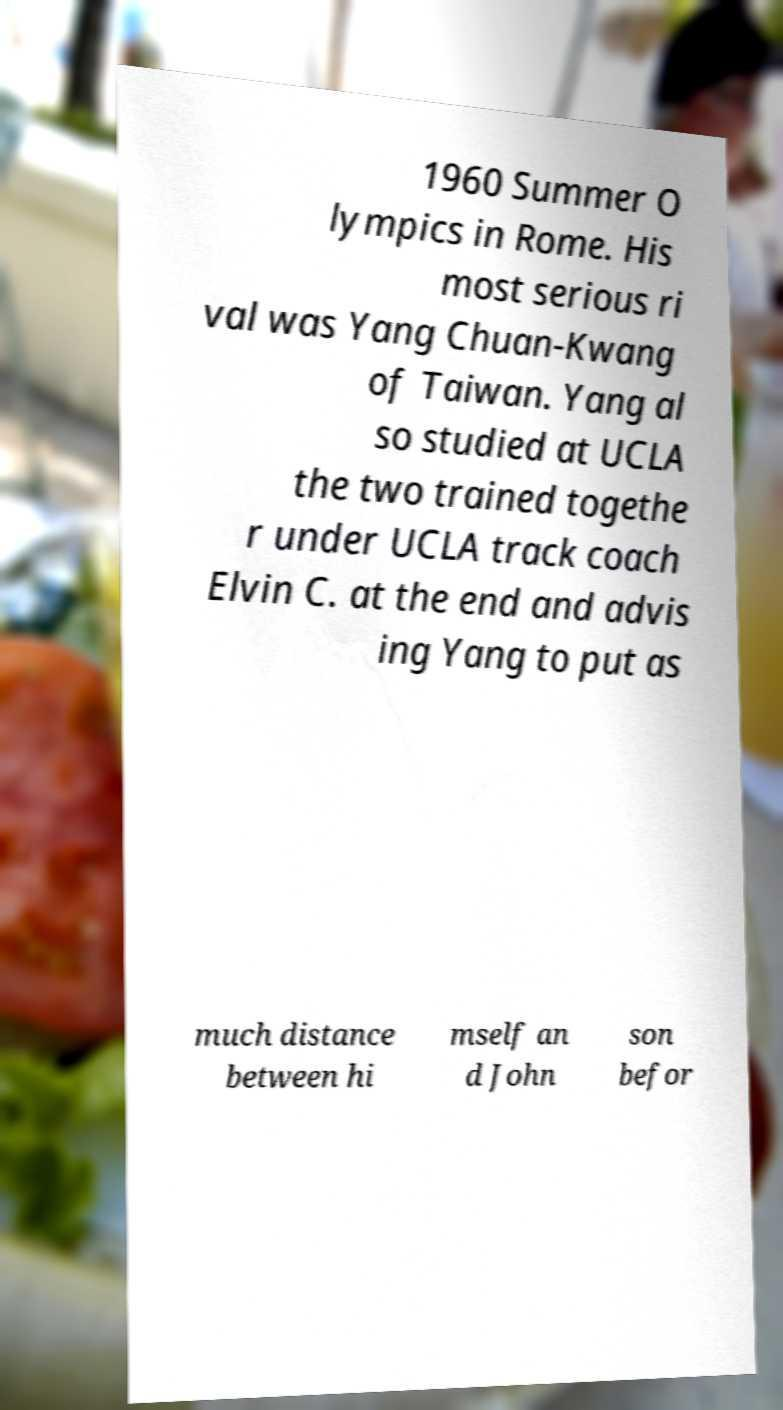There's text embedded in this image that I need extracted. Can you transcribe it verbatim? 1960 Summer O lympics in Rome. His most serious ri val was Yang Chuan-Kwang of Taiwan. Yang al so studied at UCLA the two trained togethe r under UCLA track coach Elvin C. at the end and advis ing Yang to put as much distance between hi mself an d John son befor 